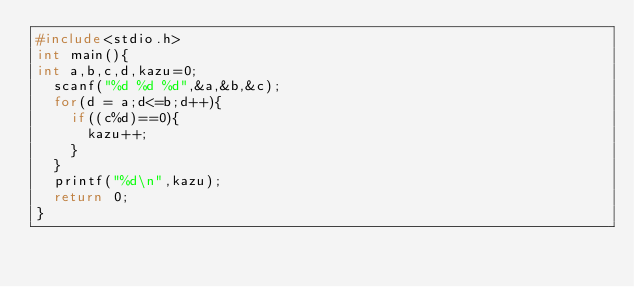Convert code to text. <code><loc_0><loc_0><loc_500><loc_500><_C++_>#include<stdio.h>
int main(){
int a,b,c,d,kazu=0;
	scanf("%d %d %d",&a,&b,&c);
	for(d = a;d<=b;d++){
		if((c%d)==0){
			kazu++;
		}
	}
	printf("%d\n",kazu);
	return 0;
}</code> 